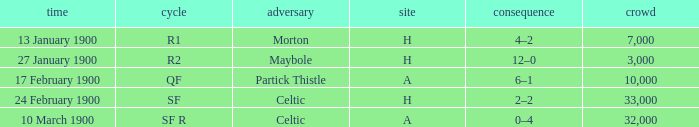How many people attended in the game against morton? 7000.0. 